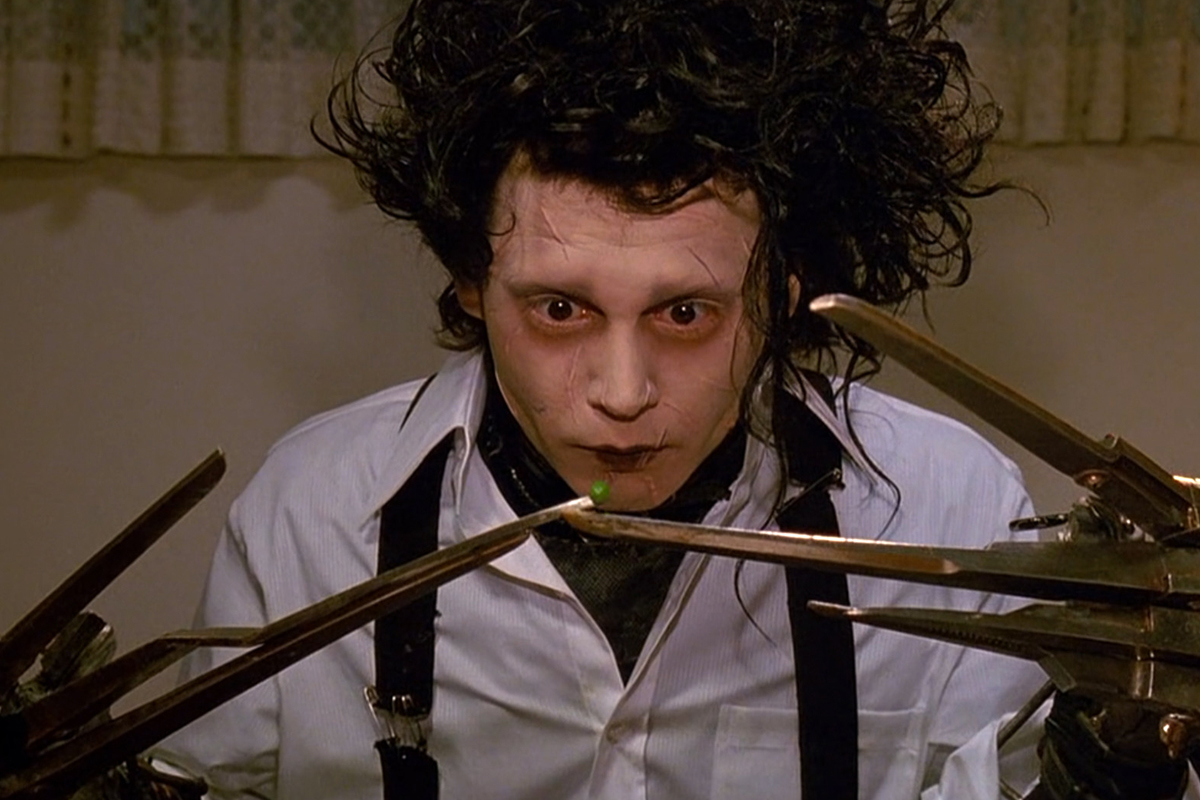Imagine Edward Scissorhands in a futuristic city. How would he adapt? In a futuristic city, Edward Scissorhands would likely find both new opportunities and challenges. His unique abilities could be embraced by a society that values technological advancement and innovation. Edward might become a renowned artist or a highly skilled craftsman, using advanced materials and tools to create astonishing works of art. On the other hand, he might still face social isolation due to his appearance. However, the futuristic setting might offer advanced technologies that could assist him in integrating better, such as specialized gloves or prosthetics to replace his scissor hands. The city's openness to diversity and innovation could help Edward find acceptance and a fulfilling role in society. Do you think Edward would enjoy living in such a bustling environment? While Edward might appreciate the opportunities and advancements of a futuristic city, the bustling environment could be overwhelming for someone so accustomed to solitude. The constant noise and activity might agitate him, but the potential to find acceptance and meaningful connections could make the experience worthwhile. With support from compassionate individuals and technology to help him adapt, Edward could slowly acclimate and even thrive, finding joy in the creativity and diversity such a city offers. 